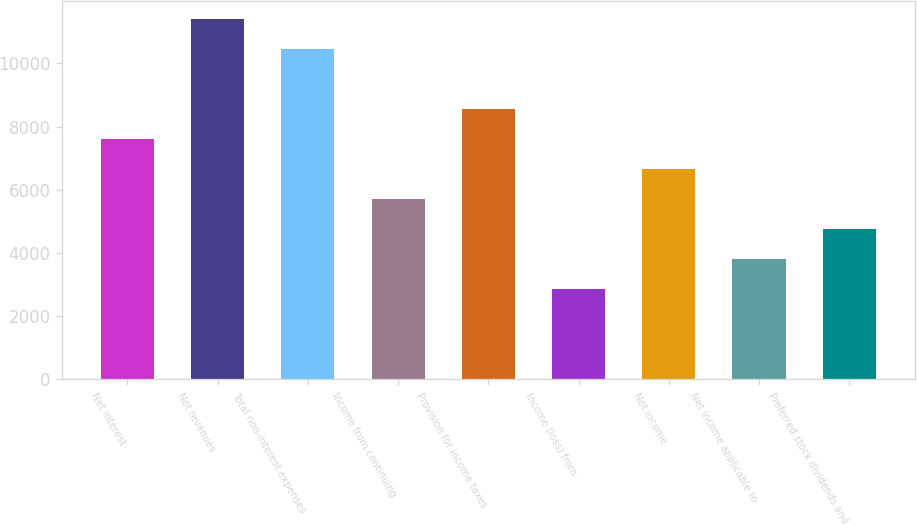<chart> <loc_0><loc_0><loc_500><loc_500><bar_chart><fcel>Net interest<fcel>Net revenues<fcel>Total non-interest expenses<fcel>Income from continuing<fcel>Provision for income taxes<fcel>Income (loss) from<fcel>Net income<fcel>Net income applicable to<fcel>Preferred stock dividends and<nl><fcel>7600.06<fcel>11400<fcel>10450<fcel>5700.1<fcel>8550.03<fcel>2850.18<fcel>6650.08<fcel>3800.15<fcel>4750.12<nl></chart> 